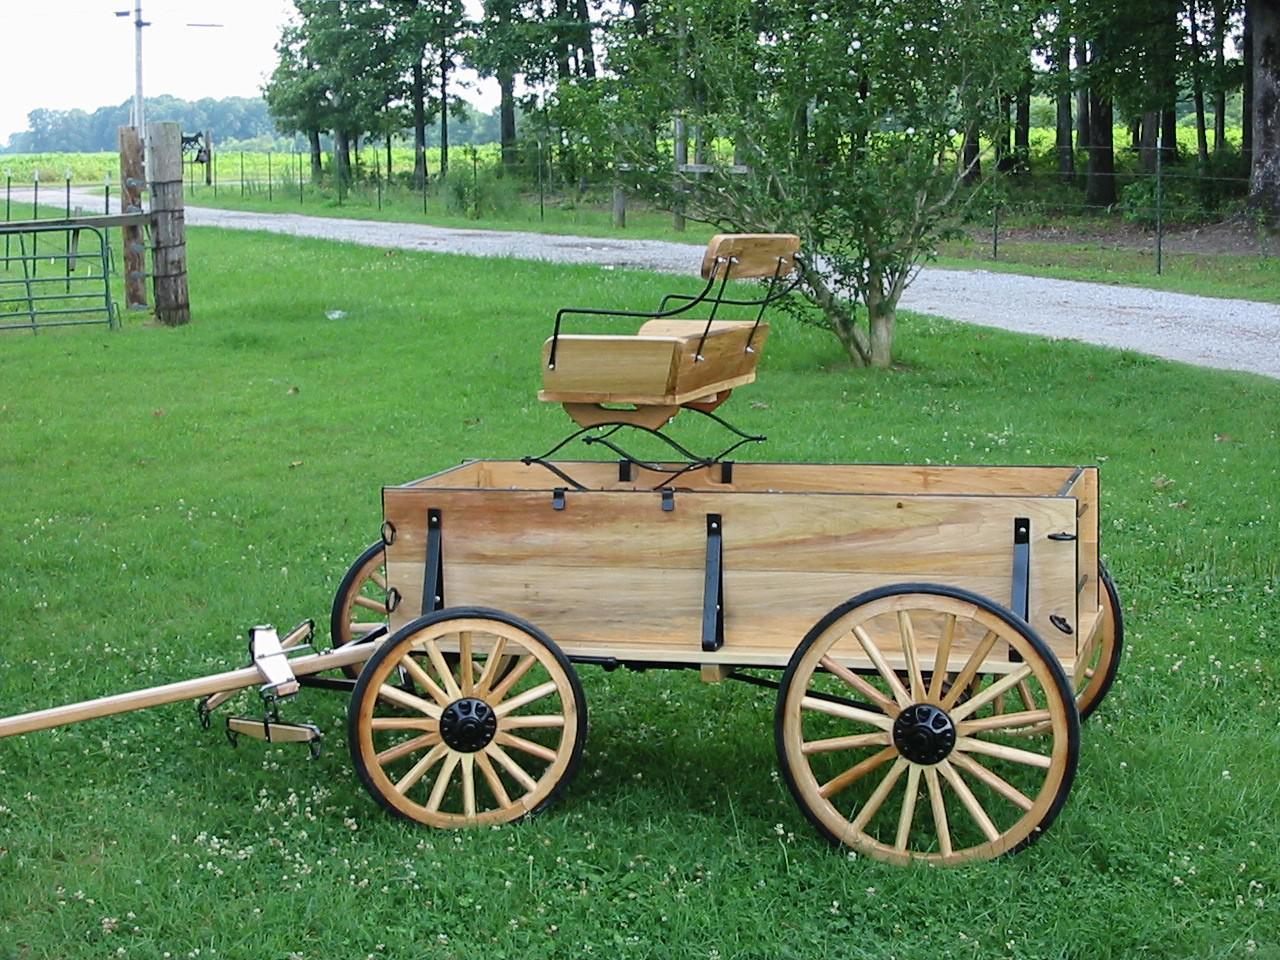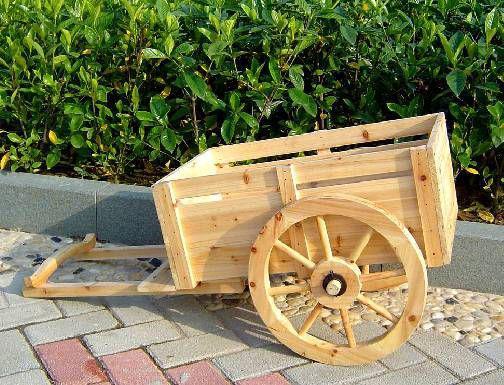The first image is the image on the left, the second image is the image on the right. Given the left and right images, does the statement "A cart in one image is equipped with only two wheels on which are rubber tires." hold true? Answer yes or no. No. 